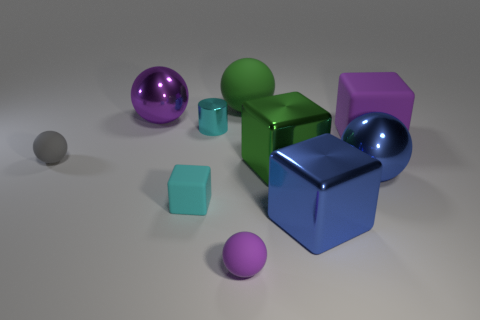How many small blue metallic cubes are there?
Offer a very short reply. 0. There is a green thing that is behind the small gray sphere; how many blue metallic balls are behind it?
Give a very brief answer. 0. There is a cylinder; does it have the same color as the block that is in front of the cyan rubber object?
Your answer should be compact. No. How many tiny matte objects are the same shape as the tiny cyan metallic thing?
Make the answer very short. 0. There is a large green object in front of the gray object; what is it made of?
Keep it short and to the point. Metal. Do the tiny object behind the gray matte object and the gray object have the same shape?
Offer a terse response. No. Is there a gray ball of the same size as the purple metal object?
Give a very brief answer. No. There is a green matte object; does it have the same shape as the rubber object right of the big green rubber ball?
Your answer should be compact. No. What is the shape of the small thing that is the same color as the small cylinder?
Your answer should be very brief. Cube. Are there fewer large rubber blocks that are in front of the large green metal block than purple rubber balls?
Provide a succinct answer. Yes. 